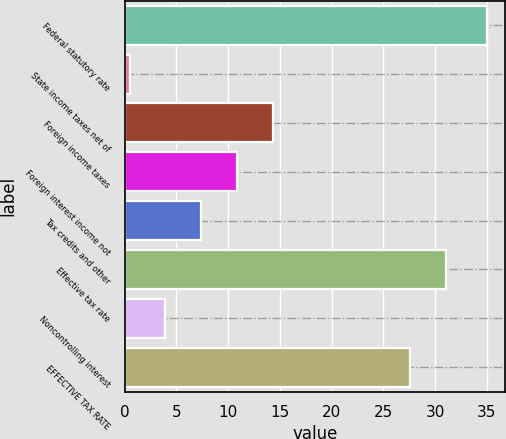<chart> <loc_0><loc_0><loc_500><loc_500><bar_chart><fcel>Federal statutory rate<fcel>State income taxes net of<fcel>Foreign income taxes<fcel>Foreign interest income not<fcel>Tax credits and other<fcel>Effective tax rate<fcel>Noncontrolling interest<fcel>EFFECTIVE TAX RATE<nl><fcel>35<fcel>0.5<fcel>14.3<fcel>10.85<fcel>7.4<fcel>31.05<fcel>3.95<fcel>27.6<nl></chart> 